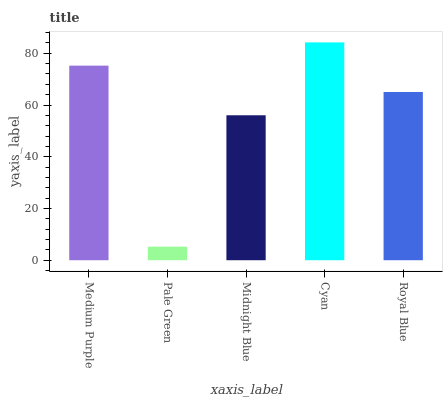Is Pale Green the minimum?
Answer yes or no. Yes. Is Cyan the maximum?
Answer yes or no. Yes. Is Midnight Blue the minimum?
Answer yes or no. No. Is Midnight Blue the maximum?
Answer yes or no. No. Is Midnight Blue greater than Pale Green?
Answer yes or no. Yes. Is Pale Green less than Midnight Blue?
Answer yes or no. Yes. Is Pale Green greater than Midnight Blue?
Answer yes or no. No. Is Midnight Blue less than Pale Green?
Answer yes or no. No. Is Royal Blue the high median?
Answer yes or no. Yes. Is Royal Blue the low median?
Answer yes or no. Yes. Is Cyan the high median?
Answer yes or no. No. Is Midnight Blue the low median?
Answer yes or no. No. 